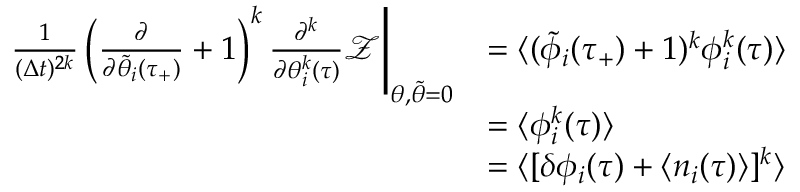Convert formula to latex. <formula><loc_0><loc_0><loc_500><loc_500>\begin{array} { r l } { \frac { 1 } { ( \Delta t ) ^ { 2 k } } \left ( \frac { \partial } { \partial \tilde { \theta } _ { i } ( \tau _ { + } ) } + 1 \right ) ^ { k } \frac { \partial ^ { k } } { \partial \theta _ { i } ^ { k } ( \tau ) } \mathcal { Z } \Big | _ { \theta , \tilde { \theta } = 0 } } & { = \langle ( \tilde { \phi } _ { i } ( \tau _ { + } ) + 1 ) ^ { k } \phi _ { i } ^ { k } ( \tau ) \rangle } \\ & { = \langle \phi _ { i } ^ { k } ( \tau ) \rangle } \\ & { = \langle [ \delta \phi _ { i } ( \tau ) + \langle n _ { i } ( \tau ) \rangle ] ^ { k } \rangle } \end{array}</formula> 